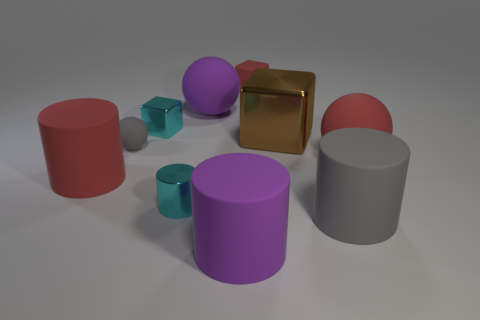What can you tell about the lighting of the scene? The lighting in the scene is diffuse, with soft shadows indicating an evenly distributed light source, possibly from above. The lack of harsh shadows or highlights suggests the environment is lit in a way to minimize glare, creating a calm atmosphere. 